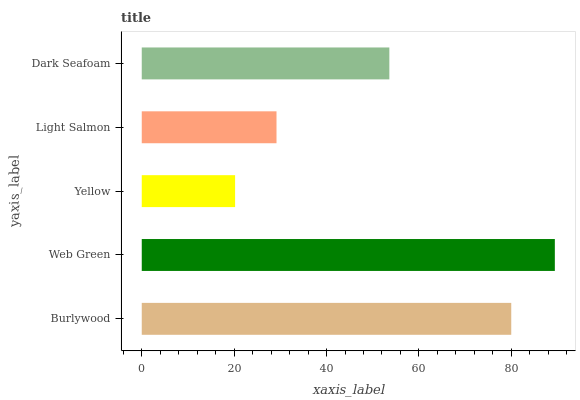Is Yellow the minimum?
Answer yes or no. Yes. Is Web Green the maximum?
Answer yes or no. Yes. Is Web Green the minimum?
Answer yes or no. No. Is Yellow the maximum?
Answer yes or no. No. Is Web Green greater than Yellow?
Answer yes or no. Yes. Is Yellow less than Web Green?
Answer yes or no. Yes. Is Yellow greater than Web Green?
Answer yes or no. No. Is Web Green less than Yellow?
Answer yes or no. No. Is Dark Seafoam the high median?
Answer yes or no. Yes. Is Dark Seafoam the low median?
Answer yes or no. Yes. Is Yellow the high median?
Answer yes or no. No. Is Light Salmon the low median?
Answer yes or no. No. 